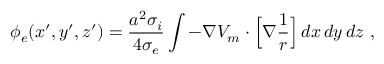Convert formula to latex. <formula><loc_0><loc_0><loc_500><loc_500>\phi _ { e } ( x ^ { \prime } , y ^ { \prime } , z ^ { \prime } ) = \frac { a ^ { 2 } \sigma _ { i } } { 4 \sigma _ { e } } \int - \nabla V _ { m } \cdot \left [ \nabla \frac { 1 } { r } \right ] \, d x \, d y \, d z \ ,</formula> 